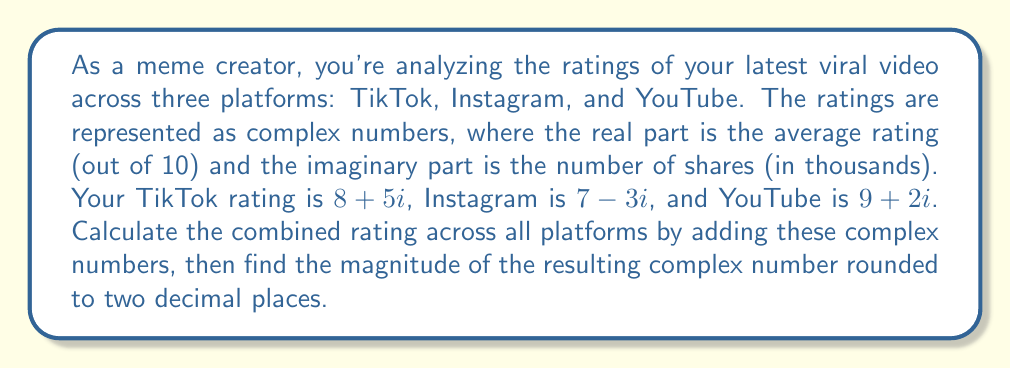What is the answer to this math problem? 1) First, we need to add the three complex numbers:

   $$(8 + 5i) + (7 - 3i) + (9 + 2i)$$

2) We can combine the real and imaginary parts separately:
   
   Real part: $8 + 7 + 9 = 24$
   Imaginary part: $5i - 3i + 2i = 4i$

3) The resulting complex number is:

   $$24 + 4i$$

4) To find the magnitude of this complex number, we use the formula:
   
   $$|a + bi| = \sqrt{a^2 + b^2}$$

5) Substituting our values:

   $$\sqrt{24^2 + 4^2} = \sqrt{576 + 16} = \sqrt{592}$$

6) Calculating and rounding to two decimal places:

   $$\sqrt{592} \approx 24.33$$
Answer: 24.33 